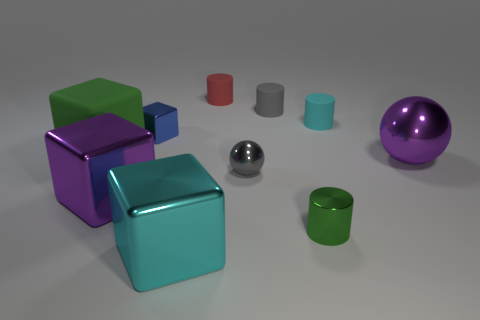What's the texture of the objects in the center? The objects in the center have smooth and shiny surfaces, reflecting light and displaying highlights and shadows indicative of a metallic or polished material.  Which object appears to be the largest? The largest object in the image appears to be the purple cube on the right, due to its more significant dimensions compared to the other objects depicted. 